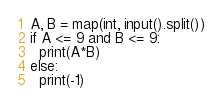<code> <loc_0><loc_0><loc_500><loc_500><_Python_>A, B = map(int, input().split())
if A <= 9 and B <= 9:
  print(A*B)
else:
  print(-1)</code> 